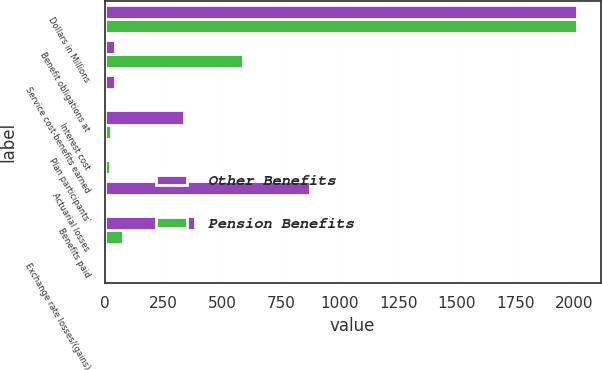Convert chart to OTSL. <chart><loc_0><loc_0><loc_500><loc_500><stacked_bar_chart><ecel><fcel>Dollars in Millions<fcel>Benefit obligations at<fcel>Service cost-benefits earned<fcel>Interest cost<fcel>Plan participants'<fcel>Actuarial losses<fcel>Benefits paid<fcel>Exchange rate losses/(gains)<nl><fcel>Other Benefits<fcel>2011<fcel>43<fcel>43<fcel>337<fcel>3<fcel>876<fcel>386<fcel>6<nl><fcel>Pension Benefits<fcel>2011<fcel>589<fcel>8<fcel>26<fcel>25<fcel>6<fcel>79<fcel>1<nl></chart> 